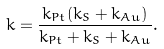<formula> <loc_0><loc_0><loc_500><loc_500>k = \frac { k _ { P t } ( k _ { S } + k _ { A u } ) } { k _ { P t } + k _ { S } + k _ { A u } } .</formula> 